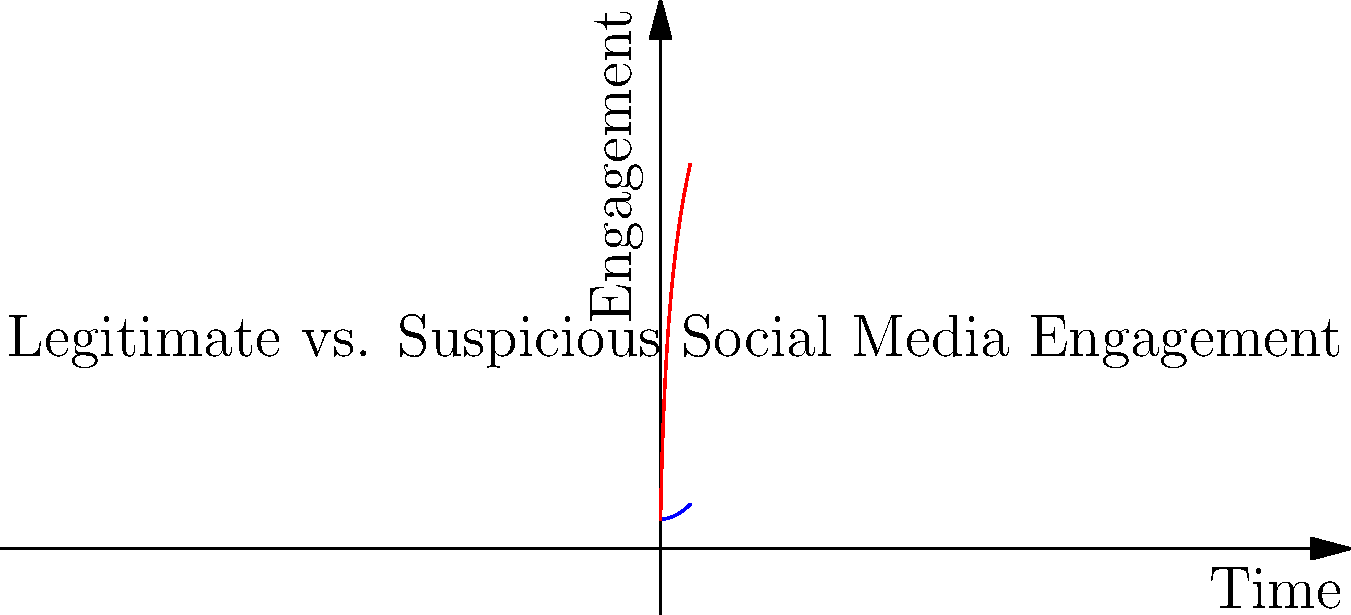As a tech journalist investigating social media trends, you come across two graphs representing engagement over time for a viral post. One shows a gradual, organic growth pattern, while the other displays an unnaturally rapid increase. What key characteristic of the suspicious engagement graph raises a red flag for potential manipulation? To analyze the graphs and identify potential manipulation:

1. Examine the blue line (Legitimate Engagement):
   - Shows a gradual, steady increase over time
   - Follows a natural, organic growth pattern
   - Resembles a quadratic function ($$f(x) = ax^2 + b$$)

2. Examine the red line (Suspicious Engagement):
   - Displays a rapid initial increase
   - Growth rate slows down significantly over time
   - Resembles a logarithmic function ($$f(x) = a \log(x+1) + b$$)

3. Compare the two graphs:
   - Legitimate engagement shows consistent growth
   - Suspicious engagement shows an unnaturally rapid initial spike

4. Identify the key characteristic of manipulation:
   - The sudden, steep increase at the beginning of the suspicious engagement graph
   - This pattern is often associated with artificial inflation of engagement metrics

5. Consider implications for a tech journalist:
   - Such patterns may indicate the use of bots, fake accounts, or paid engagement
   - This insight is crucial for reporting on social media trends and misinformation

The key characteristic that raises a red flag is the unnaturally rapid initial increase in the suspicious engagement graph, which is inconsistent with organic growth patterns.
Answer: Unnaturally rapid initial increase 